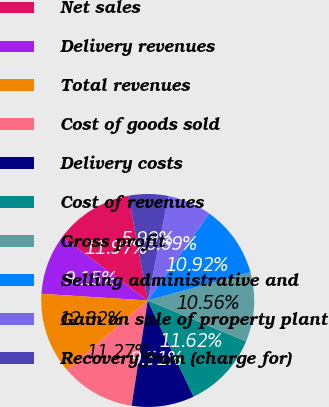Convert chart to OTSL. <chart><loc_0><loc_0><loc_500><loc_500><pie_chart><fcel>Net sales<fcel>Delivery revenues<fcel>Total revenues<fcel>Cost of goods sold<fcel>Delivery costs<fcel>Cost of revenues<fcel>Gross profit<fcel>Selling administrative and<fcel>Gain on sale of property plant<fcel>Recovery from (charge for)<nl><fcel>11.97%<fcel>9.15%<fcel>12.32%<fcel>11.27%<fcel>9.51%<fcel>11.62%<fcel>10.56%<fcel>10.92%<fcel>6.69%<fcel>5.99%<nl></chart> 